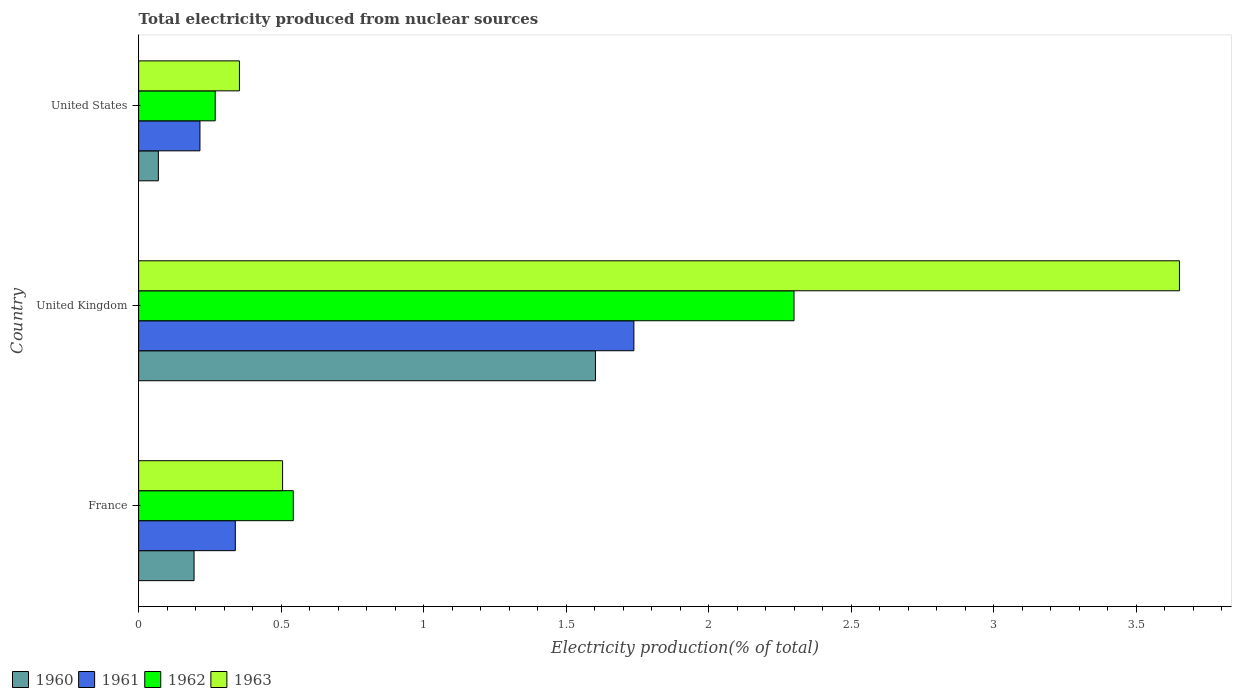How many different coloured bars are there?
Ensure brevity in your answer.  4. How many bars are there on the 2nd tick from the bottom?
Make the answer very short. 4. In how many cases, is the number of bars for a given country not equal to the number of legend labels?
Offer a terse response. 0. What is the total electricity produced in 1960 in United States?
Keep it short and to the point. 0.07. Across all countries, what is the maximum total electricity produced in 1963?
Keep it short and to the point. 3.65. Across all countries, what is the minimum total electricity produced in 1962?
Your answer should be very brief. 0.27. In which country was the total electricity produced in 1960 maximum?
Provide a short and direct response. United Kingdom. What is the total total electricity produced in 1961 in the graph?
Provide a short and direct response. 2.29. What is the difference between the total electricity produced in 1962 in France and that in United Kingdom?
Provide a short and direct response. -1.76. What is the difference between the total electricity produced in 1961 in France and the total electricity produced in 1960 in United Kingdom?
Your response must be concise. -1.26. What is the average total electricity produced in 1961 per country?
Ensure brevity in your answer.  0.76. What is the difference between the total electricity produced in 1960 and total electricity produced in 1963 in United Kingdom?
Your answer should be very brief. -2.05. In how many countries, is the total electricity produced in 1961 greater than 2.2 %?
Offer a very short reply. 0. What is the ratio of the total electricity produced in 1961 in France to that in United States?
Your response must be concise. 1.58. Is the total electricity produced in 1963 in France less than that in United States?
Offer a terse response. No. Is the difference between the total electricity produced in 1960 in France and United Kingdom greater than the difference between the total electricity produced in 1963 in France and United Kingdom?
Your answer should be very brief. Yes. What is the difference between the highest and the second highest total electricity produced in 1963?
Ensure brevity in your answer.  3.15. What is the difference between the highest and the lowest total electricity produced in 1961?
Your response must be concise. 1.52. What does the 3rd bar from the top in United Kingdom represents?
Make the answer very short. 1961. What is the difference between two consecutive major ticks on the X-axis?
Provide a succinct answer. 0.5. Are the values on the major ticks of X-axis written in scientific E-notation?
Offer a terse response. No. Does the graph contain any zero values?
Your answer should be very brief. No. Does the graph contain grids?
Offer a terse response. No. Where does the legend appear in the graph?
Make the answer very short. Bottom left. How many legend labels are there?
Provide a succinct answer. 4. What is the title of the graph?
Ensure brevity in your answer.  Total electricity produced from nuclear sources. What is the label or title of the X-axis?
Keep it short and to the point. Electricity production(% of total). What is the Electricity production(% of total) in 1960 in France?
Offer a terse response. 0.19. What is the Electricity production(% of total) in 1961 in France?
Give a very brief answer. 0.34. What is the Electricity production(% of total) of 1962 in France?
Keep it short and to the point. 0.54. What is the Electricity production(% of total) in 1963 in France?
Offer a terse response. 0.51. What is the Electricity production(% of total) of 1960 in United Kingdom?
Your response must be concise. 1.6. What is the Electricity production(% of total) in 1961 in United Kingdom?
Your answer should be very brief. 1.74. What is the Electricity production(% of total) in 1962 in United Kingdom?
Your answer should be compact. 2.3. What is the Electricity production(% of total) of 1963 in United Kingdom?
Offer a very short reply. 3.65. What is the Electricity production(% of total) of 1960 in United States?
Your response must be concise. 0.07. What is the Electricity production(% of total) in 1961 in United States?
Keep it short and to the point. 0.22. What is the Electricity production(% of total) of 1962 in United States?
Offer a terse response. 0.27. What is the Electricity production(% of total) of 1963 in United States?
Provide a succinct answer. 0.35. Across all countries, what is the maximum Electricity production(% of total) in 1960?
Make the answer very short. 1.6. Across all countries, what is the maximum Electricity production(% of total) in 1961?
Provide a succinct answer. 1.74. Across all countries, what is the maximum Electricity production(% of total) of 1962?
Offer a very short reply. 2.3. Across all countries, what is the maximum Electricity production(% of total) in 1963?
Provide a short and direct response. 3.65. Across all countries, what is the minimum Electricity production(% of total) of 1960?
Offer a very short reply. 0.07. Across all countries, what is the minimum Electricity production(% of total) in 1961?
Your response must be concise. 0.22. Across all countries, what is the minimum Electricity production(% of total) in 1962?
Offer a very short reply. 0.27. Across all countries, what is the minimum Electricity production(% of total) in 1963?
Your answer should be compact. 0.35. What is the total Electricity production(% of total) in 1960 in the graph?
Ensure brevity in your answer.  1.87. What is the total Electricity production(% of total) in 1961 in the graph?
Your answer should be compact. 2.29. What is the total Electricity production(% of total) of 1962 in the graph?
Keep it short and to the point. 3.11. What is the total Electricity production(% of total) in 1963 in the graph?
Your answer should be very brief. 4.51. What is the difference between the Electricity production(% of total) of 1960 in France and that in United Kingdom?
Your response must be concise. -1.41. What is the difference between the Electricity production(% of total) of 1961 in France and that in United Kingdom?
Your response must be concise. -1.4. What is the difference between the Electricity production(% of total) of 1962 in France and that in United Kingdom?
Your answer should be compact. -1.76. What is the difference between the Electricity production(% of total) in 1963 in France and that in United Kingdom?
Your answer should be compact. -3.15. What is the difference between the Electricity production(% of total) in 1960 in France and that in United States?
Provide a succinct answer. 0.13. What is the difference between the Electricity production(% of total) in 1961 in France and that in United States?
Give a very brief answer. 0.12. What is the difference between the Electricity production(% of total) of 1962 in France and that in United States?
Give a very brief answer. 0.27. What is the difference between the Electricity production(% of total) of 1963 in France and that in United States?
Provide a short and direct response. 0.15. What is the difference between the Electricity production(% of total) in 1960 in United Kingdom and that in United States?
Make the answer very short. 1.53. What is the difference between the Electricity production(% of total) of 1961 in United Kingdom and that in United States?
Offer a very short reply. 1.52. What is the difference between the Electricity production(% of total) of 1962 in United Kingdom and that in United States?
Offer a very short reply. 2.03. What is the difference between the Electricity production(% of total) of 1963 in United Kingdom and that in United States?
Keep it short and to the point. 3.3. What is the difference between the Electricity production(% of total) of 1960 in France and the Electricity production(% of total) of 1961 in United Kingdom?
Keep it short and to the point. -1.54. What is the difference between the Electricity production(% of total) in 1960 in France and the Electricity production(% of total) in 1962 in United Kingdom?
Give a very brief answer. -2.11. What is the difference between the Electricity production(% of total) of 1960 in France and the Electricity production(% of total) of 1963 in United Kingdom?
Offer a very short reply. -3.46. What is the difference between the Electricity production(% of total) of 1961 in France and the Electricity production(% of total) of 1962 in United Kingdom?
Your answer should be very brief. -1.96. What is the difference between the Electricity production(% of total) in 1961 in France and the Electricity production(% of total) in 1963 in United Kingdom?
Offer a very short reply. -3.31. What is the difference between the Electricity production(% of total) in 1962 in France and the Electricity production(% of total) in 1963 in United Kingdom?
Your response must be concise. -3.11. What is the difference between the Electricity production(% of total) in 1960 in France and the Electricity production(% of total) in 1961 in United States?
Provide a short and direct response. -0.02. What is the difference between the Electricity production(% of total) of 1960 in France and the Electricity production(% of total) of 1962 in United States?
Your response must be concise. -0.07. What is the difference between the Electricity production(% of total) in 1960 in France and the Electricity production(% of total) in 1963 in United States?
Provide a succinct answer. -0.16. What is the difference between the Electricity production(% of total) in 1961 in France and the Electricity production(% of total) in 1962 in United States?
Give a very brief answer. 0.07. What is the difference between the Electricity production(% of total) of 1961 in France and the Electricity production(% of total) of 1963 in United States?
Ensure brevity in your answer.  -0.01. What is the difference between the Electricity production(% of total) in 1962 in France and the Electricity production(% of total) in 1963 in United States?
Offer a very short reply. 0.19. What is the difference between the Electricity production(% of total) in 1960 in United Kingdom and the Electricity production(% of total) in 1961 in United States?
Keep it short and to the point. 1.39. What is the difference between the Electricity production(% of total) of 1960 in United Kingdom and the Electricity production(% of total) of 1962 in United States?
Offer a terse response. 1.33. What is the difference between the Electricity production(% of total) in 1960 in United Kingdom and the Electricity production(% of total) in 1963 in United States?
Offer a very short reply. 1.25. What is the difference between the Electricity production(% of total) in 1961 in United Kingdom and the Electricity production(% of total) in 1962 in United States?
Offer a very short reply. 1.47. What is the difference between the Electricity production(% of total) of 1961 in United Kingdom and the Electricity production(% of total) of 1963 in United States?
Your answer should be compact. 1.38. What is the difference between the Electricity production(% of total) in 1962 in United Kingdom and the Electricity production(% of total) in 1963 in United States?
Give a very brief answer. 1.95. What is the average Electricity production(% of total) in 1960 per country?
Keep it short and to the point. 0.62. What is the average Electricity production(% of total) of 1961 per country?
Make the answer very short. 0.76. What is the average Electricity production(% of total) in 1962 per country?
Provide a short and direct response. 1.04. What is the average Electricity production(% of total) of 1963 per country?
Give a very brief answer. 1.5. What is the difference between the Electricity production(% of total) of 1960 and Electricity production(% of total) of 1961 in France?
Your answer should be very brief. -0.14. What is the difference between the Electricity production(% of total) in 1960 and Electricity production(% of total) in 1962 in France?
Provide a succinct answer. -0.35. What is the difference between the Electricity production(% of total) in 1960 and Electricity production(% of total) in 1963 in France?
Your answer should be very brief. -0.31. What is the difference between the Electricity production(% of total) in 1961 and Electricity production(% of total) in 1962 in France?
Your answer should be compact. -0.2. What is the difference between the Electricity production(% of total) of 1961 and Electricity production(% of total) of 1963 in France?
Your answer should be very brief. -0.17. What is the difference between the Electricity production(% of total) of 1962 and Electricity production(% of total) of 1963 in France?
Give a very brief answer. 0.04. What is the difference between the Electricity production(% of total) in 1960 and Electricity production(% of total) in 1961 in United Kingdom?
Your answer should be very brief. -0.13. What is the difference between the Electricity production(% of total) of 1960 and Electricity production(% of total) of 1962 in United Kingdom?
Offer a very short reply. -0.7. What is the difference between the Electricity production(% of total) of 1960 and Electricity production(% of total) of 1963 in United Kingdom?
Ensure brevity in your answer.  -2.05. What is the difference between the Electricity production(% of total) in 1961 and Electricity production(% of total) in 1962 in United Kingdom?
Your response must be concise. -0.56. What is the difference between the Electricity production(% of total) in 1961 and Electricity production(% of total) in 1963 in United Kingdom?
Your answer should be compact. -1.91. What is the difference between the Electricity production(% of total) of 1962 and Electricity production(% of total) of 1963 in United Kingdom?
Make the answer very short. -1.35. What is the difference between the Electricity production(% of total) of 1960 and Electricity production(% of total) of 1961 in United States?
Offer a terse response. -0.15. What is the difference between the Electricity production(% of total) in 1960 and Electricity production(% of total) in 1962 in United States?
Make the answer very short. -0.2. What is the difference between the Electricity production(% of total) of 1960 and Electricity production(% of total) of 1963 in United States?
Your response must be concise. -0.28. What is the difference between the Electricity production(% of total) of 1961 and Electricity production(% of total) of 1962 in United States?
Provide a short and direct response. -0.05. What is the difference between the Electricity production(% of total) in 1961 and Electricity production(% of total) in 1963 in United States?
Your answer should be compact. -0.14. What is the difference between the Electricity production(% of total) of 1962 and Electricity production(% of total) of 1963 in United States?
Your answer should be very brief. -0.09. What is the ratio of the Electricity production(% of total) in 1960 in France to that in United Kingdom?
Provide a short and direct response. 0.12. What is the ratio of the Electricity production(% of total) of 1961 in France to that in United Kingdom?
Your answer should be very brief. 0.2. What is the ratio of the Electricity production(% of total) of 1962 in France to that in United Kingdom?
Offer a terse response. 0.24. What is the ratio of the Electricity production(% of total) of 1963 in France to that in United Kingdom?
Provide a short and direct response. 0.14. What is the ratio of the Electricity production(% of total) of 1960 in France to that in United States?
Provide a succinct answer. 2.81. What is the ratio of the Electricity production(% of total) of 1961 in France to that in United States?
Provide a short and direct response. 1.58. What is the ratio of the Electricity production(% of total) in 1962 in France to that in United States?
Ensure brevity in your answer.  2.02. What is the ratio of the Electricity production(% of total) of 1963 in France to that in United States?
Your answer should be compact. 1.43. What is the ratio of the Electricity production(% of total) in 1960 in United Kingdom to that in United States?
Give a very brief answer. 23.14. What is the ratio of the Electricity production(% of total) in 1961 in United Kingdom to that in United States?
Ensure brevity in your answer.  8.08. What is the ratio of the Electricity production(% of total) in 1962 in United Kingdom to that in United States?
Provide a succinct answer. 8.56. What is the ratio of the Electricity production(% of total) in 1963 in United Kingdom to that in United States?
Give a very brief answer. 10.32. What is the difference between the highest and the second highest Electricity production(% of total) in 1960?
Your answer should be very brief. 1.41. What is the difference between the highest and the second highest Electricity production(% of total) in 1961?
Your answer should be compact. 1.4. What is the difference between the highest and the second highest Electricity production(% of total) of 1962?
Your answer should be very brief. 1.76. What is the difference between the highest and the second highest Electricity production(% of total) of 1963?
Your answer should be very brief. 3.15. What is the difference between the highest and the lowest Electricity production(% of total) of 1960?
Offer a terse response. 1.53. What is the difference between the highest and the lowest Electricity production(% of total) in 1961?
Offer a very short reply. 1.52. What is the difference between the highest and the lowest Electricity production(% of total) in 1962?
Your answer should be compact. 2.03. What is the difference between the highest and the lowest Electricity production(% of total) of 1963?
Give a very brief answer. 3.3. 